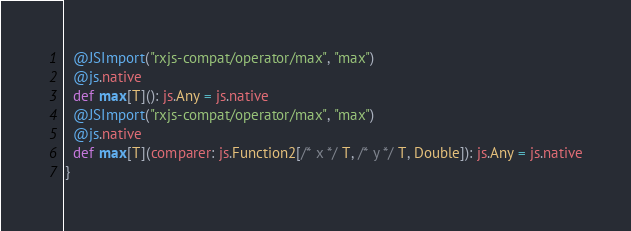<code> <loc_0><loc_0><loc_500><loc_500><_Scala_>  @JSImport("rxjs-compat/operator/max", "max")
  @js.native
  def max[T](): js.Any = js.native
  @JSImport("rxjs-compat/operator/max", "max")
  @js.native
  def max[T](comparer: js.Function2[/* x */ T, /* y */ T, Double]): js.Any = js.native
}
</code> 